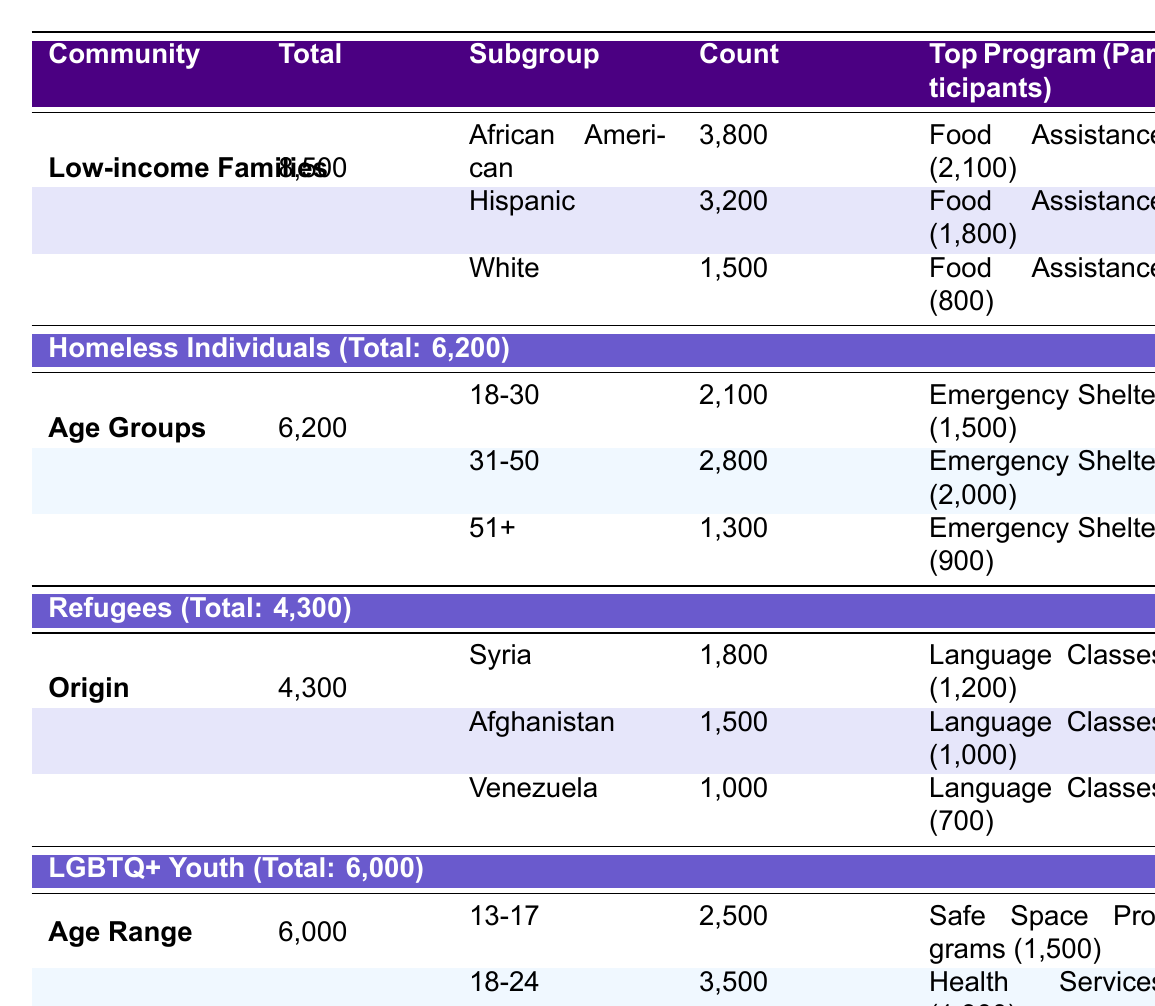What is the total number of individuals served in Chicago? The table states that the total served is 25,000 individuals.
Answer: 25,000 How many individuals from the Hispanic community were served? The Hispanic community count is listed as 3,200 in the Low-income Families group.
Answer: 3,200 What is the most populated age group among homeless individuals? The age group of 31-50 has the highest count with 2,800 individuals.
Answer: 31-50 How many refugees from Afghanistan were served? The table shows that 1,500 refugees from Afghanistan were served.
Answer: 1,500 Which program had the highest number of participants for Low-income Families? The Food Assistance program had the highest participants with 2,100.
Answer: Food Assistance What is the total count of LGBTQ+ Youth served in the 18-24 age range? The total count for the 18-24 age range is 3,500 individuals.
Answer: 3,500 What is the total number of Low-income Families served and what percentage does that represent of the total individuals served? The total number of Low-income Families served is 8,500. The percentage is calculated as (8,500 / 25,000) * 100 = 34%.
Answer: 34% Which ethic group under Low-income Families received the most support? The African American group received the most support, with 3,800 individuals.
Answer: African American How many people received Emergency Shelter among those aged 51 and over in the homeless group? The table shows that 900 individuals aged 51+ received Emergency Shelter.
Answer: 900 If we combine the total counts for all groups, is the total served more than 30,000? The totals for the groups sum up to 25,000, which is less than 30,000.
Answer: No What is the average number of participants across all top programs listed? The total participants across all top programs are (2,100 + 1,800 + 800 + 1,500 + 2,000 + 900 + 1,200 + 1,000 + 700 + 1,500 + 1,000 + 1,300) =  19,600, and dividing this by 12 programs gives an average of approximately 1,633.33.
Answer: 1,633.33 What is the total number of participants in the Language Classes program for refugees? The table lists 1200 for Syrian refugees, 1000 for Afghan refugees, and 700 for Venezuelan refugees. The total is 1200 + 1000 + 700 = 2900.
Answer: 2,900 